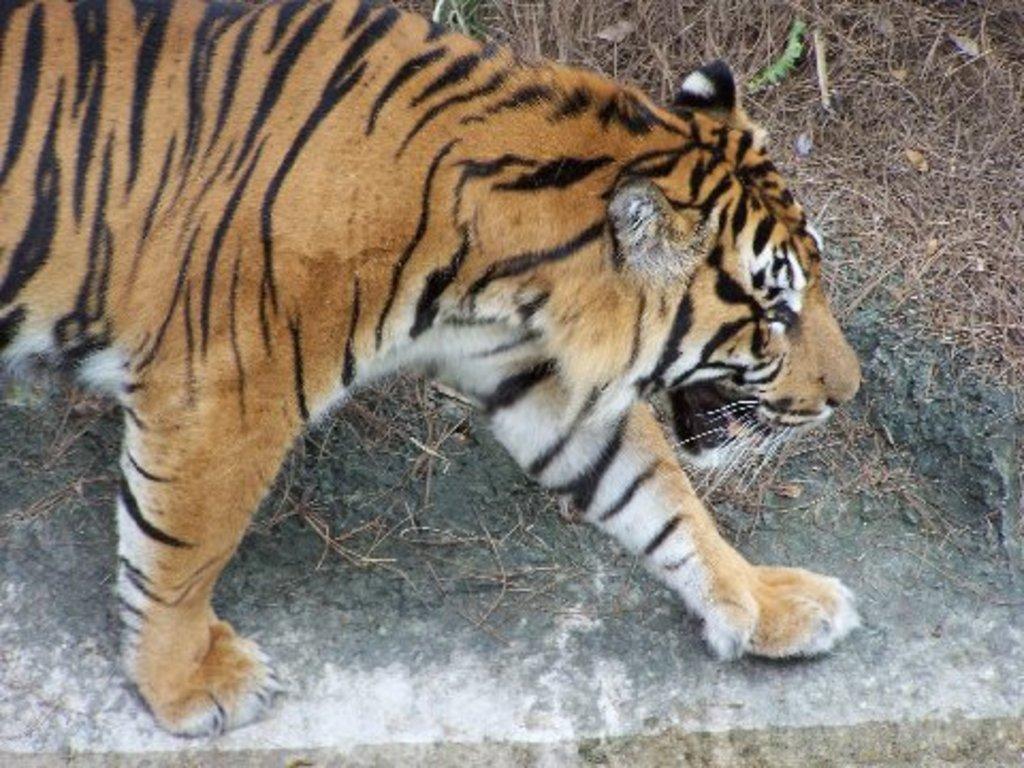In one or two sentences, can you explain what this image depicts? In the image I can see a tiger which is on the ground on which there are some dry stems. 